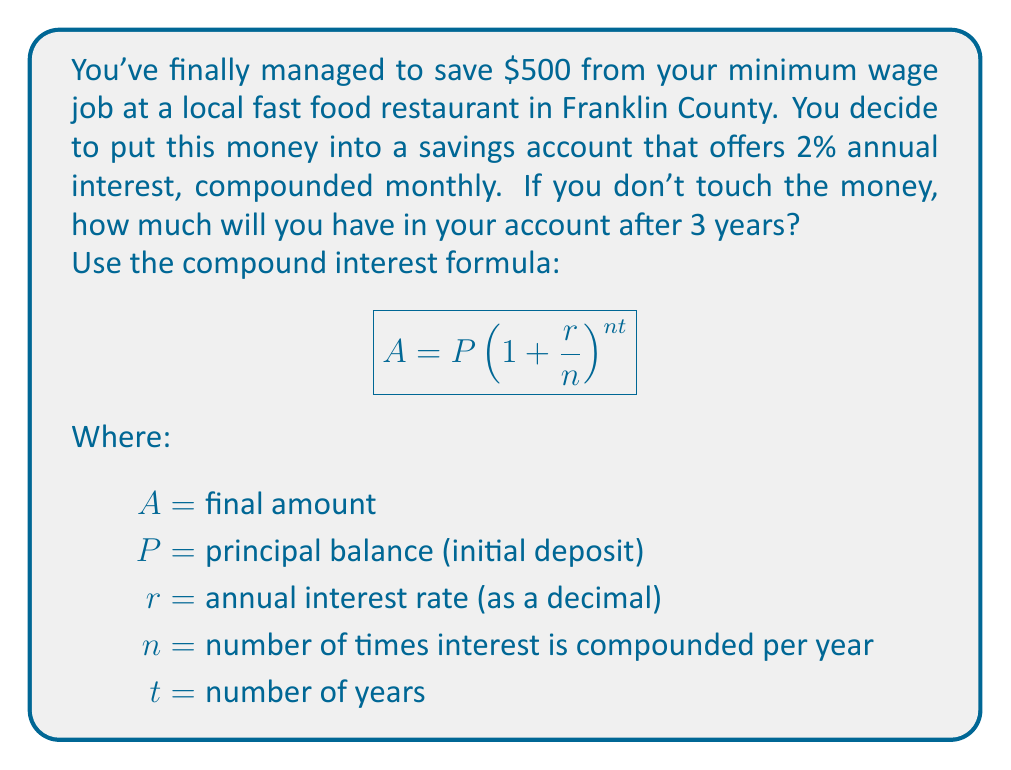Can you solve this math problem? Let's break this down step-by-step:

1) We have the following values:
   $P = 500$ (initial deposit)
   $r = 0.02$ (2% annual interest rate as a decimal)
   $n = 12$ (compounded monthly, so 12 times per year)
   $t = 3$ (3 years)

2) Now, let's plug these values into the formula:

   $$A = 500(1 + \frac{0.02}{12})^{12 * 3}$$

3) Simplify inside the parentheses:
   $$A = 500(1 + 0.001667)^{36}$$

4) Calculate the exponent:
   $$A = 500(1.001667)^{36}$$

5) Use a calculator to compute this value:
   $$A = 500 * 1.061678$$
   $$A = 530.84$$

6) Round to the nearest cent:
   $$A = 530.84$$

Therefore, after 3 years, you will have $530.84 in your savings account.
Answer: $530.84 